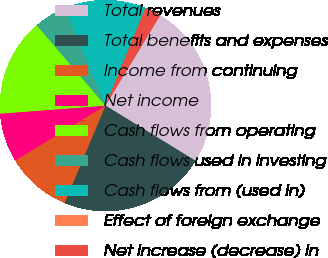Convert chart to OTSL. <chart><loc_0><loc_0><loc_500><loc_500><pie_chart><fcel>Total revenues<fcel>Total benefits and expenses<fcel>Income from continuing<fcel>Net income<fcel>Cash flows from operating<fcel>Cash flows used in investing<fcel>Cash flows from (used in)<fcel>Effect of foreign exchange<fcel>Net increase (decrease) in<nl><fcel>25.07%<fcel>22.58%<fcel>9.97%<fcel>7.48%<fcel>14.95%<fcel>4.99%<fcel>12.46%<fcel>0.0%<fcel>2.49%<nl></chart> 